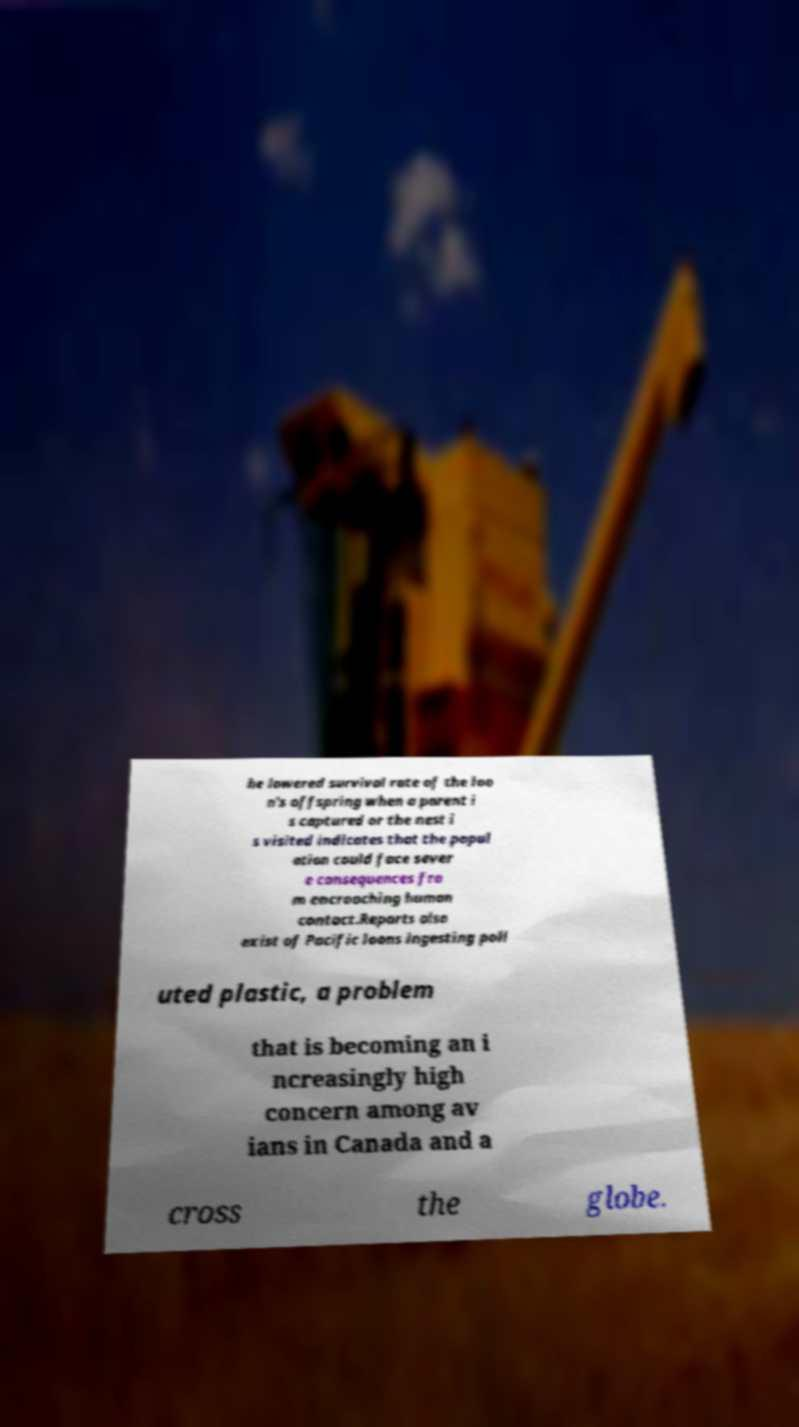Please read and relay the text visible in this image. What does it say? he lowered survival rate of the loo n's offspring when a parent i s captured or the nest i s visited indicates that the popul ation could face sever e consequences fro m encroaching human contact.Reports also exist of Pacific loons ingesting poll uted plastic, a problem that is becoming an i ncreasingly high concern among av ians in Canada and a cross the globe. 